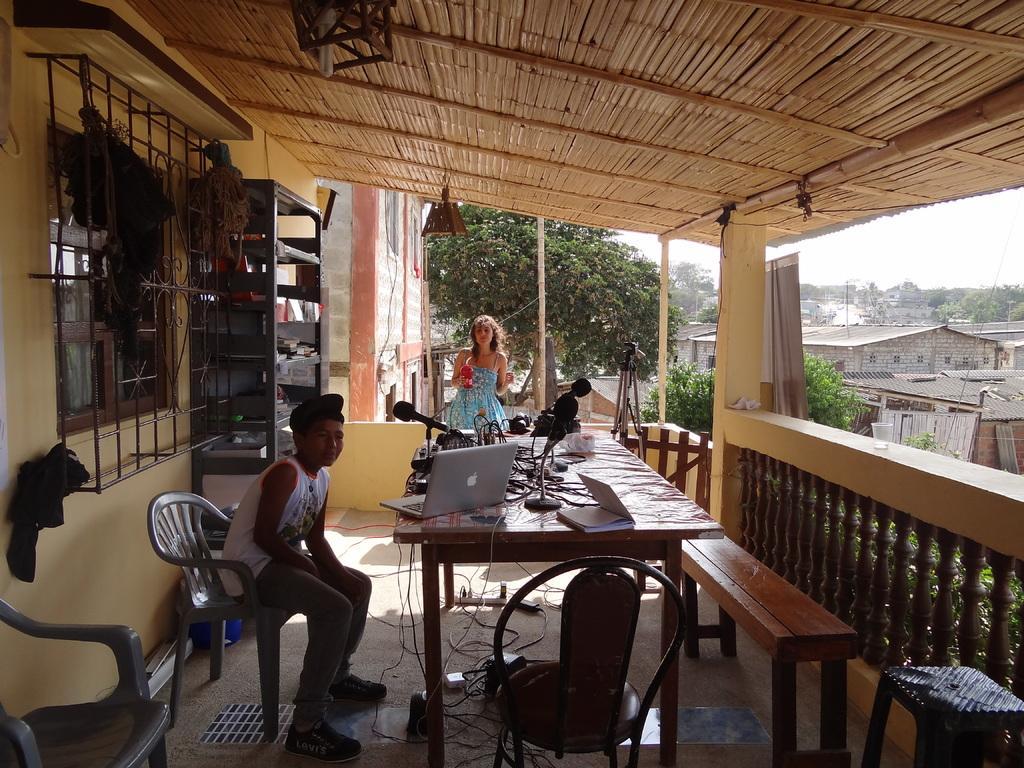Describe this image in one or two sentences. In the picture we can see a house, trees, plants, sky and table. On table we can see a laptop's, books, microphones, wires, and near to it there are chairs and benches and a window and we can see a boy and a woman. 